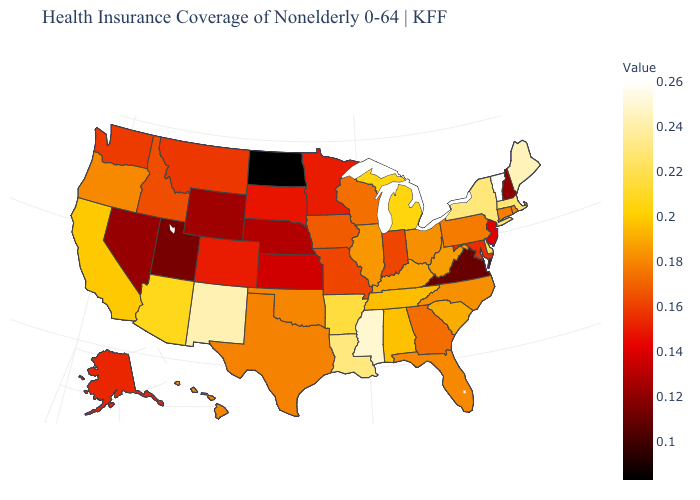Does Alaska have a higher value than Wyoming?
Short answer required. Yes. Among the states that border Wisconsin , which have the highest value?
Concise answer only. Michigan. 